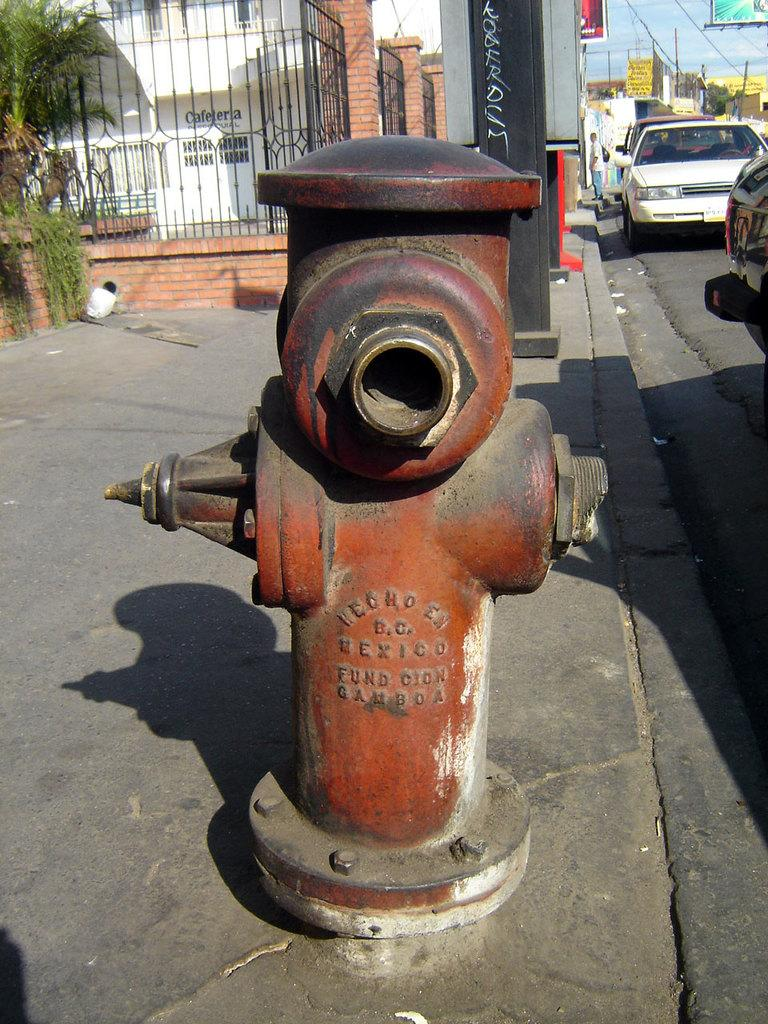What type of structures can be seen in the image? There are buildings in the image. What other natural elements are present in the image? There are trees in the image. What type of barrier can be seen in the image? There is an iron railing in the image. What type of material is used for the boards in the image? The boards in the image are made of a material that is not specified in the facts. What part of the natural environment is visible in the image? The sky is visible in the image. What type of transportation can be seen in the image? There are vehicles on the road in the image. What object is located in front of the image? There is a fire-hydrant in front of the image. What book is the person reading in the image? There is no person or book present in the image. What is the size of the fire-hydrant in the image? The size of the fire-hydrant is not specified in the facts. 